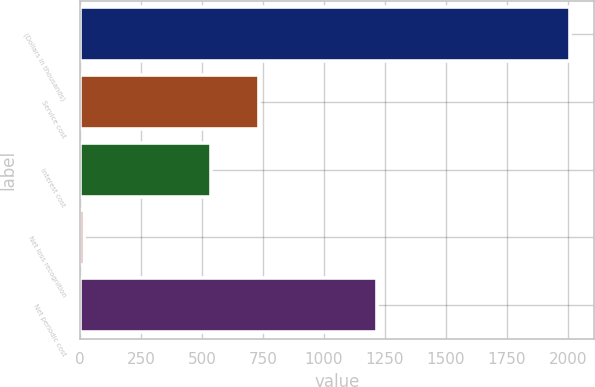<chart> <loc_0><loc_0><loc_500><loc_500><bar_chart><fcel>(Dollars in thousands)<fcel>Service cost<fcel>Interest cost<fcel>Net loss recognition<fcel>Net periodic cost<nl><fcel>2007<fcel>734.9<fcel>536<fcel>18<fcel>1217<nl></chart> 